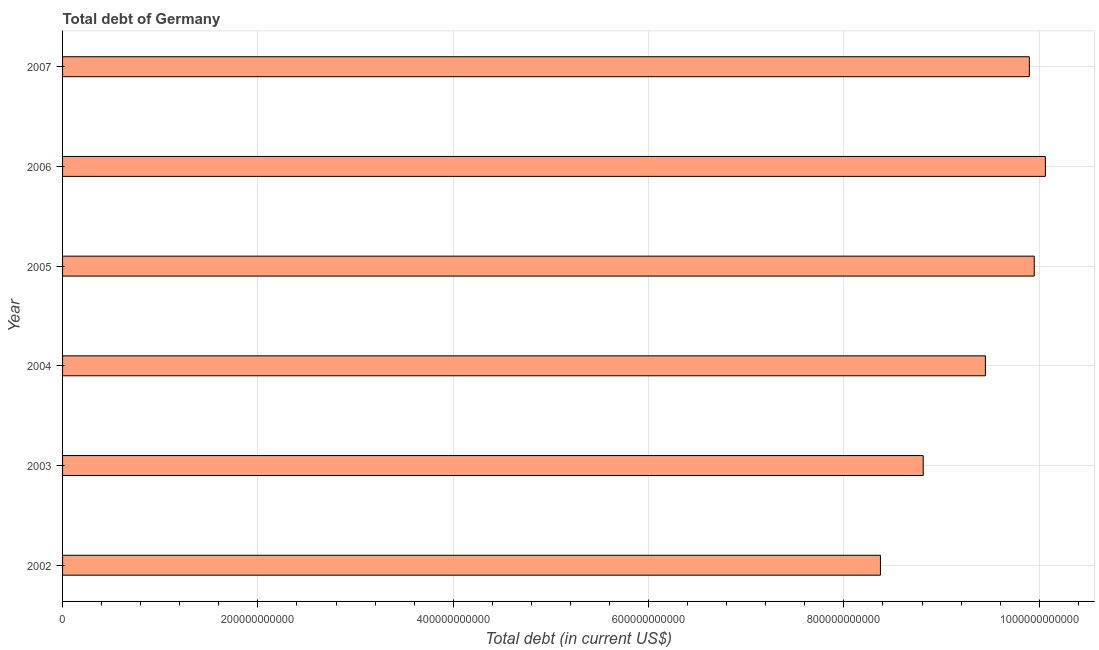Does the graph contain any zero values?
Your answer should be very brief. No. Does the graph contain grids?
Keep it short and to the point. Yes. What is the title of the graph?
Offer a terse response. Total debt of Germany. What is the label or title of the X-axis?
Give a very brief answer. Total debt (in current US$). What is the total debt in 2007?
Provide a short and direct response. 9.90e+11. Across all years, what is the maximum total debt?
Your response must be concise. 1.01e+12. Across all years, what is the minimum total debt?
Your answer should be very brief. 8.37e+11. In which year was the total debt maximum?
Offer a very short reply. 2006. What is the sum of the total debt?
Your answer should be very brief. 5.65e+12. What is the difference between the total debt in 2003 and 2004?
Give a very brief answer. -6.37e+1. What is the average total debt per year?
Offer a terse response. 9.42e+11. What is the median total debt?
Give a very brief answer. 9.67e+11. Do a majority of the years between 2007 and 2005 (inclusive) have total debt greater than 280000000000 US$?
Provide a short and direct response. Yes. What is the ratio of the total debt in 2002 to that in 2004?
Your answer should be very brief. 0.89. Is the total debt in 2002 less than that in 2007?
Provide a succinct answer. Yes. Is the difference between the total debt in 2002 and 2005 greater than the difference between any two years?
Keep it short and to the point. No. What is the difference between the highest and the second highest total debt?
Give a very brief answer. 1.14e+1. What is the difference between the highest and the lowest total debt?
Make the answer very short. 1.69e+11. In how many years, is the total debt greater than the average total debt taken over all years?
Make the answer very short. 4. Are all the bars in the graph horizontal?
Provide a short and direct response. Yes. What is the difference between two consecutive major ticks on the X-axis?
Provide a short and direct response. 2.00e+11. Are the values on the major ticks of X-axis written in scientific E-notation?
Your answer should be compact. No. What is the Total debt (in current US$) in 2002?
Provide a short and direct response. 8.37e+11. What is the Total debt (in current US$) in 2003?
Your answer should be compact. 8.81e+11. What is the Total debt (in current US$) in 2004?
Provide a succinct answer. 9.45e+11. What is the Total debt (in current US$) in 2005?
Keep it short and to the point. 9.95e+11. What is the Total debt (in current US$) in 2006?
Provide a short and direct response. 1.01e+12. What is the Total debt (in current US$) in 2007?
Ensure brevity in your answer.  9.90e+11. What is the difference between the Total debt (in current US$) in 2002 and 2003?
Offer a very short reply. -4.38e+1. What is the difference between the Total debt (in current US$) in 2002 and 2004?
Make the answer very short. -1.07e+11. What is the difference between the Total debt (in current US$) in 2002 and 2005?
Provide a short and direct response. -1.57e+11. What is the difference between the Total debt (in current US$) in 2002 and 2006?
Give a very brief answer. -1.69e+11. What is the difference between the Total debt (in current US$) in 2002 and 2007?
Ensure brevity in your answer.  -1.52e+11. What is the difference between the Total debt (in current US$) in 2003 and 2004?
Make the answer very short. -6.37e+1. What is the difference between the Total debt (in current US$) in 2003 and 2005?
Your answer should be compact. -1.14e+11. What is the difference between the Total debt (in current US$) in 2003 and 2006?
Ensure brevity in your answer.  -1.25e+11. What is the difference between the Total debt (in current US$) in 2003 and 2007?
Your answer should be compact. -1.09e+11. What is the difference between the Total debt (in current US$) in 2004 and 2005?
Keep it short and to the point. -5.00e+1. What is the difference between the Total debt (in current US$) in 2004 and 2006?
Offer a very short reply. -6.14e+1. What is the difference between the Total debt (in current US$) in 2004 and 2007?
Make the answer very short. -4.50e+1. What is the difference between the Total debt (in current US$) in 2005 and 2006?
Your answer should be very brief. -1.14e+1. What is the difference between the Total debt (in current US$) in 2005 and 2007?
Your answer should be compact. 5.04e+09. What is the difference between the Total debt (in current US$) in 2006 and 2007?
Give a very brief answer. 1.64e+1. What is the ratio of the Total debt (in current US$) in 2002 to that in 2004?
Your answer should be very brief. 0.89. What is the ratio of the Total debt (in current US$) in 2002 to that in 2005?
Give a very brief answer. 0.84. What is the ratio of the Total debt (in current US$) in 2002 to that in 2006?
Provide a succinct answer. 0.83. What is the ratio of the Total debt (in current US$) in 2002 to that in 2007?
Offer a very short reply. 0.85. What is the ratio of the Total debt (in current US$) in 2003 to that in 2004?
Ensure brevity in your answer.  0.93. What is the ratio of the Total debt (in current US$) in 2003 to that in 2005?
Make the answer very short. 0.89. What is the ratio of the Total debt (in current US$) in 2003 to that in 2006?
Offer a terse response. 0.88. What is the ratio of the Total debt (in current US$) in 2003 to that in 2007?
Ensure brevity in your answer.  0.89. What is the ratio of the Total debt (in current US$) in 2004 to that in 2005?
Provide a short and direct response. 0.95. What is the ratio of the Total debt (in current US$) in 2004 to that in 2006?
Your answer should be compact. 0.94. What is the ratio of the Total debt (in current US$) in 2004 to that in 2007?
Offer a terse response. 0.95. 